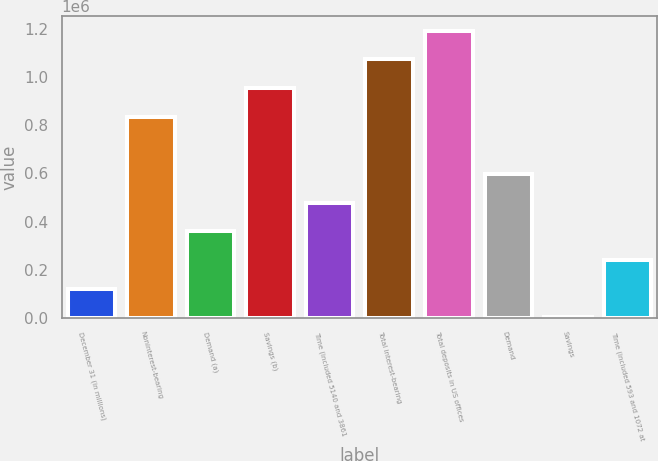Convert chart to OTSL. <chart><loc_0><loc_0><loc_500><loc_500><bar_chart><fcel>December 31 (in millions)<fcel>Noninterest-bearing<fcel>Demand (a)<fcel>Savings (b)<fcel>Time (included 5140 and 3861<fcel>Total interest-bearing<fcel>Total deposits in US offices<fcel>Demand<fcel>Savings<fcel>Time (included 593 and 1072 at<nl><fcel>120263<fcel>835816<fcel>358781<fcel>955075<fcel>478040<fcel>1.07433e+06<fcel>1.19359e+06<fcel>597298<fcel>1004<fcel>239522<nl></chart> 